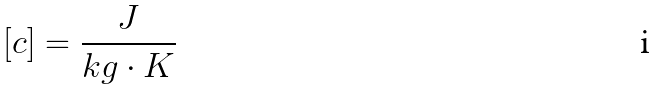Convert formula to latex. <formula><loc_0><loc_0><loc_500><loc_500>[ c ] = \frac { J } { k g \cdot K }</formula> 